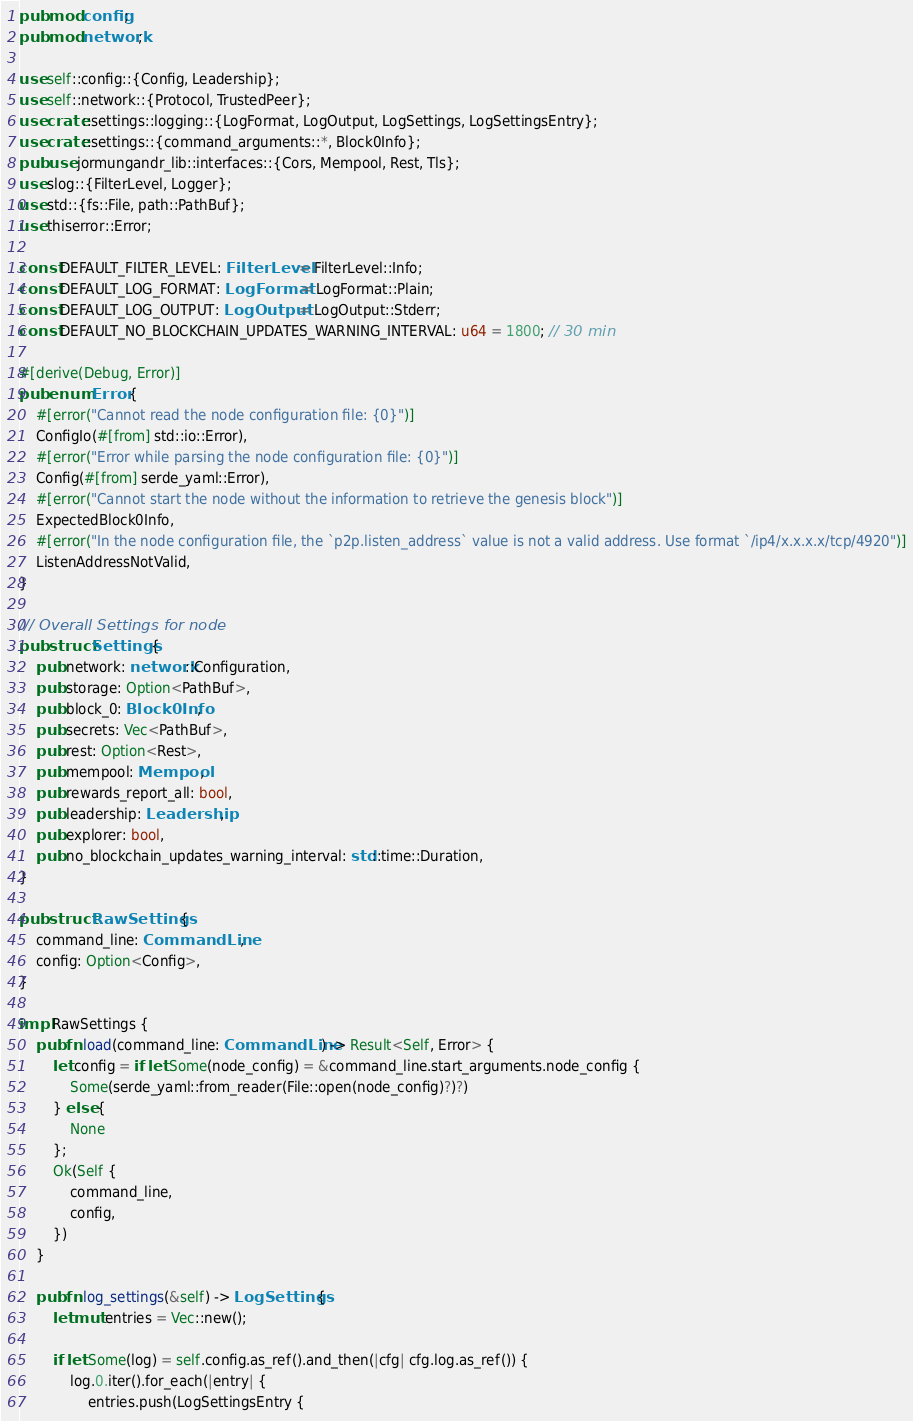<code> <loc_0><loc_0><loc_500><loc_500><_Rust_>pub mod config;
pub mod network;

use self::config::{Config, Leadership};
use self::network::{Protocol, TrustedPeer};
use crate::settings::logging::{LogFormat, LogOutput, LogSettings, LogSettingsEntry};
use crate::settings::{command_arguments::*, Block0Info};
pub use jormungandr_lib::interfaces::{Cors, Mempool, Rest, Tls};
use slog::{FilterLevel, Logger};
use std::{fs::File, path::PathBuf};
use thiserror::Error;

const DEFAULT_FILTER_LEVEL: FilterLevel = FilterLevel::Info;
const DEFAULT_LOG_FORMAT: LogFormat = LogFormat::Plain;
const DEFAULT_LOG_OUTPUT: LogOutput = LogOutput::Stderr;
const DEFAULT_NO_BLOCKCHAIN_UPDATES_WARNING_INTERVAL: u64 = 1800; // 30 min

#[derive(Debug, Error)]
pub enum Error {
    #[error("Cannot read the node configuration file: {0}")]
    ConfigIo(#[from] std::io::Error),
    #[error("Error while parsing the node configuration file: {0}")]
    Config(#[from] serde_yaml::Error),
    #[error("Cannot start the node without the information to retrieve the genesis block")]
    ExpectedBlock0Info,
    #[error("In the node configuration file, the `p2p.listen_address` value is not a valid address. Use format `/ip4/x.x.x.x/tcp/4920")]
    ListenAddressNotValid,
}

/// Overall Settings for node
pub struct Settings {
    pub network: network::Configuration,
    pub storage: Option<PathBuf>,
    pub block_0: Block0Info,
    pub secrets: Vec<PathBuf>,
    pub rest: Option<Rest>,
    pub mempool: Mempool,
    pub rewards_report_all: bool,
    pub leadership: Leadership,
    pub explorer: bool,
    pub no_blockchain_updates_warning_interval: std::time::Duration,
}

pub struct RawSettings {
    command_line: CommandLine,
    config: Option<Config>,
}

impl RawSettings {
    pub fn load(command_line: CommandLine) -> Result<Self, Error> {
        let config = if let Some(node_config) = &command_line.start_arguments.node_config {
            Some(serde_yaml::from_reader(File::open(node_config)?)?)
        } else {
            None
        };
        Ok(Self {
            command_line,
            config,
        })
    }

    pub fn log_settings(&self) -> LogSettings {
        let mut entries = Vec::new();

        if let Some(log) = self.config.as_ref().and_then(|cfg| cfg.log.as_ref()) {
            log.0.iter().for_each(|entry| {
                entries.push(LogSettingsEntry {</code> 